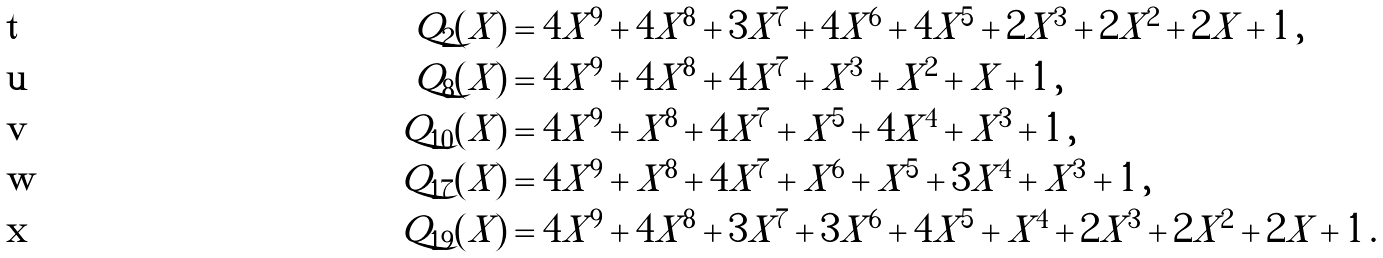<formula> <loc_0><loc_0><loc_500><loc_500>Q _ { 2 } ( X ) & = { { 4 } X ^ { 9 } + { 4 } X ^ { 8 } + { 3 } X ^ { 7 } + { 4 } X ^ { 6 } + { 4 } X ^ { 5 } + { 2 } X ^ { 3 } + { 2 } X ^ { 2 } + { 2 } X + 1 } \, , \\ Q _ { 8 } ( X ) & = { { 4 } X ^ { 9 } + { 4 } X ^ { 8 } + { 4 } X ^ { 7 } + X ^ { 3 } + X ^ { 2 } + X + 1 } \, , \\ Q _ { 1 0 } ( X ) & = { { 4 } X ^ { 9 } + X ^ { 8 } + { 4 } X ^ { 7 } + X ^ { 5 } + { 4 } X ^ { 4 } + X ^ { 3 } + 1 } \, , \\ Q _ { 1 7 } ( X ) & = { { 4 } X ^ { 9 } + X ^ { 8 } + { 4 } X ^ { 7 } + X ^ { 6 } + X ^ { 5 } + { 3 } X ^ { 4 } + X ^ { 3 } + 1 } \, , \\ Q _ { 1 9 } ( X ) & = { { 4 } X ^ { 9 } + { 4 } X ^ { 8 } + { 3 } X ^ { 7 } + { 3 } X ^ { 6 } + { 4 } X ^ { 5 } + X ^ { 4 } + { 2 } X ^ { 3 } + { 2 } X ^ { 2 } + { 2 } X + 1 } \, .</formula> 